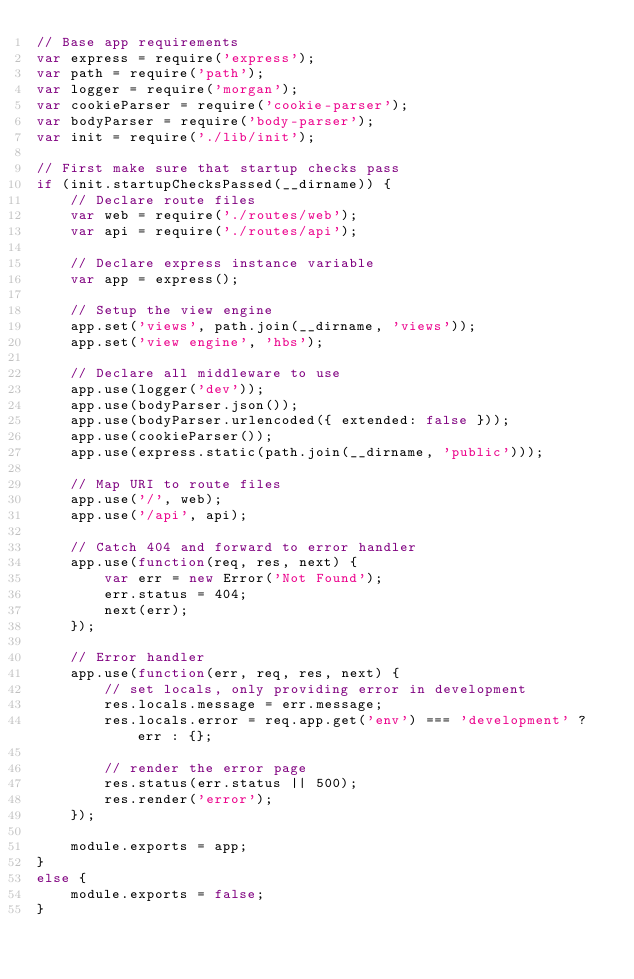Convert code to text. <code><loc_0><loc_0><loc_500><loc_500><_JavaScript_>// Base app requirements
var express = require('express');
var path = require('path');
var logger = require('morgan');
var cookieParser = require('cookie-parser');
var bodyParser = require('body-parser');
var init = require('./lib/init');

// First make sure that startup checks pass
if (init.startupChecksPassed(__dirname)) {
	// Declare route files
	var web = require('./routes/web');
	var api = require('./routes/api');
	
	// Declare express instance variable
	var app = express();
	
	// Setup the view engine
	app.set('views', path.join(__dirname, 'views'));
	app.set('view engine', 'hbs');
	
	// Declare all middleware to use
	app.use(logger('dev'));
	app.use(bodyParser.json());
	app.use(bodyParser.urlencoded({ extended: false }));
	app.use(cookieParser());
	app.use(express.static(path.join(__dirname, 'public')));
	
	// Map URI to route files
	app.use('/', web);
	app.use('/api', api);
	
	// Catch 404 and forward to error handler
	app.use(function(req, res, next) {
		var err = new Error('Not Found');
		err.status = 404;
		next(err);
	});
	
	// Error handler
	app.use(function(err, req, res, next) {
		// set locals, only providing error in development
		res.locals.message = err.message;
		res.locals.error = req.app.get('env') === 'development' ? err : {};
		
		// render the error page
		res.status(err.status || 500);
		res.render('error');
	});

	module.exports = app;
}
else {
	module.exports = false;
}</code> 